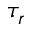Convert formula to latex. <formula><loc_0><loc_0><loc_500><loc_500>\tau _ { r }</formula> 